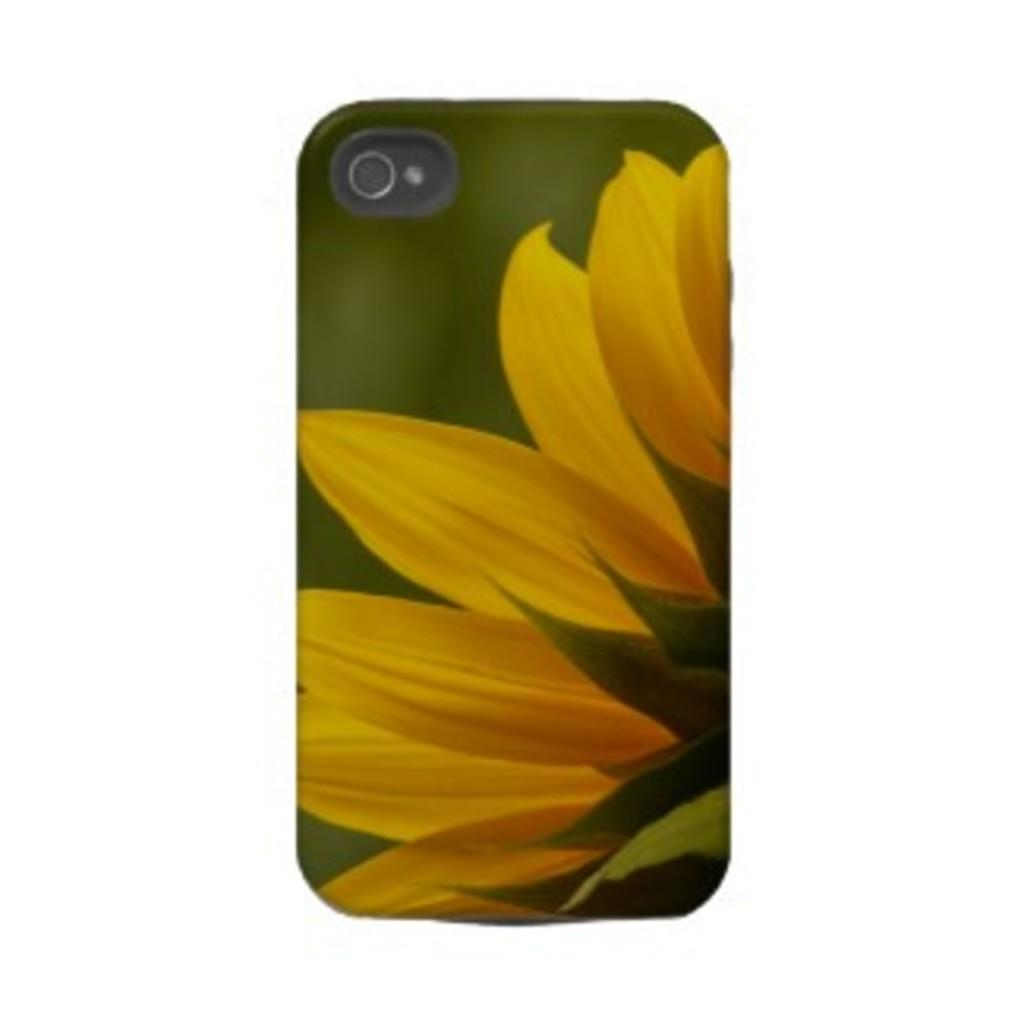What object is the main focus of the image? The main focus of the image is a mobile case. What design is featured on the mobile case? The mobile case has a flower design on it. What type of wrist accessory is visible in the image? There is no wrist accessory present in the image; it features a mobile case with a flower design. Can you describe the shirt worn by the flower in the image? There is no flower or shirt present in the image; it only shows a mobile case with a flower design. 